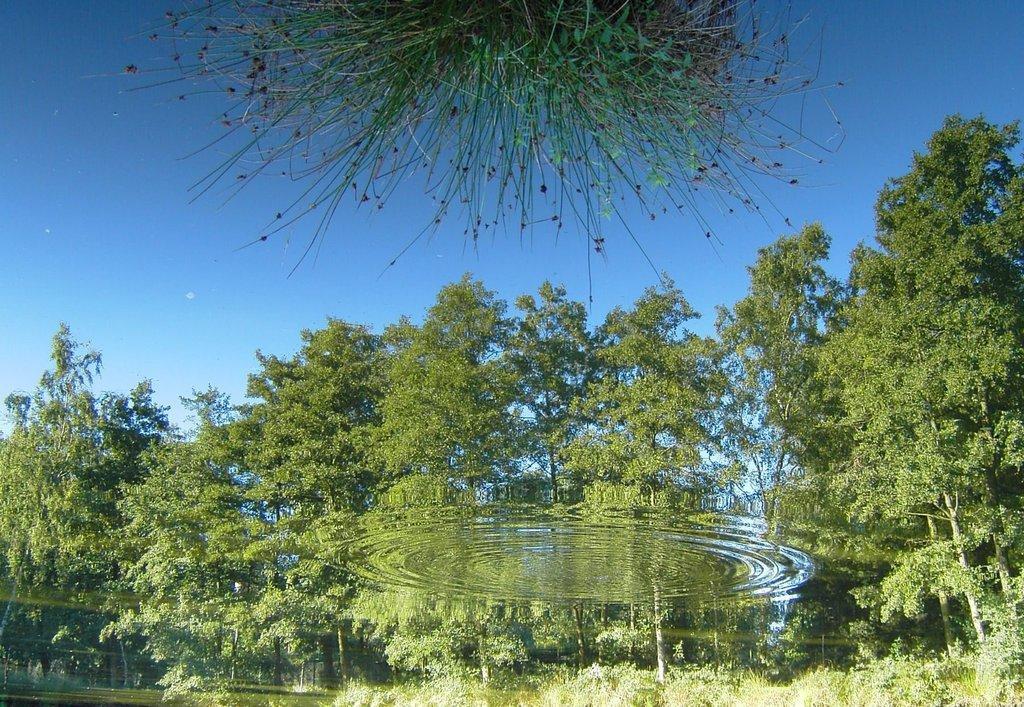Could you give a brief overview of what you see in this image? In the image there is water. On the water there is a reflection of trees. In the image there are many trees and also there is a sky. To the top middle of the image there is a plant with leaves. 